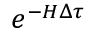<formula> <loc_0><loc_0><loc_500><loc_500>e ^ { - H \Delta \tau }</formula> 